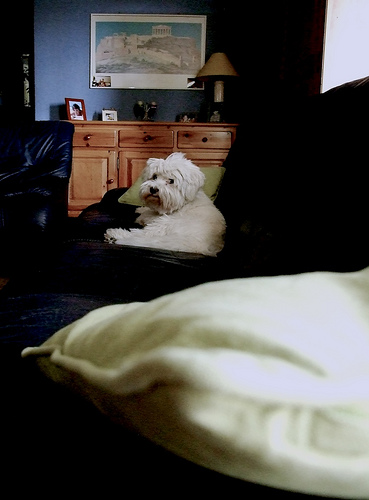<image>
Is there a chair in front of the cabinet? Yes. The chair is positioned in front of the cabinet, appearing closer to the camera viewpoint. 